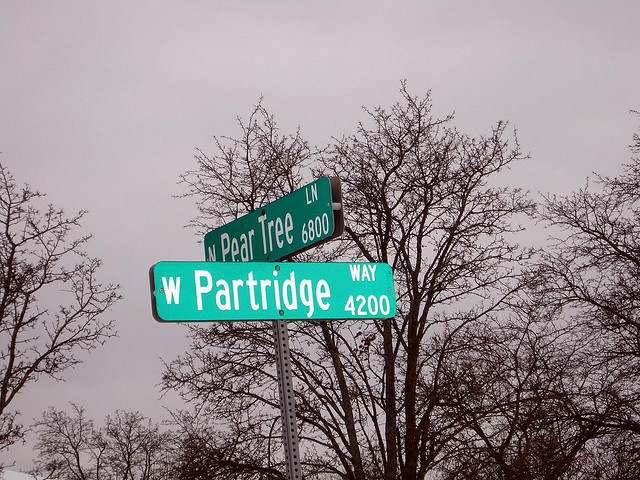Please transcribe the text information in this image. Partridge WAY 4200 W 6800 LN Tree Pear N 